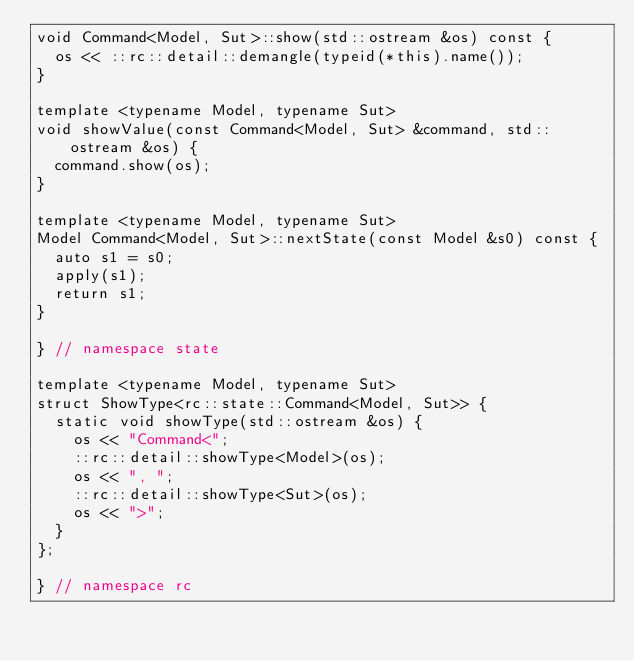<code> <loc_0><loc_0><loc_500><loc_500><_C++_>void Command<Model, Sut>::show(std::ostream &os) const {
  os << ::rc::detail::demangle(typeid(*this).name());
}

template <typename Model, typename Sut>
void showValue(const Command<Model, Sut> &command, std::ostream &os) {
  command.show(os);
}

template <typename Model, typename Sut>
Model Command<Model, Sut>::nextState(const Model &s0) const {
  auto s1 = s0;
  apply(s1);
  return s1;
}

} // namespace state

template <typename Model, typename Sut>
struct ShowType<rc::state::Command<Model, Sut>> {
  static void showType(std::ostream &os) {
    os << "Command<";
    ::rc::detail::showType<Model>(os);
    os << ", ";
    ::rc::detail::showType<Sut>(os);
    os << ">";
  }
};

} // namespace rc
</code> 